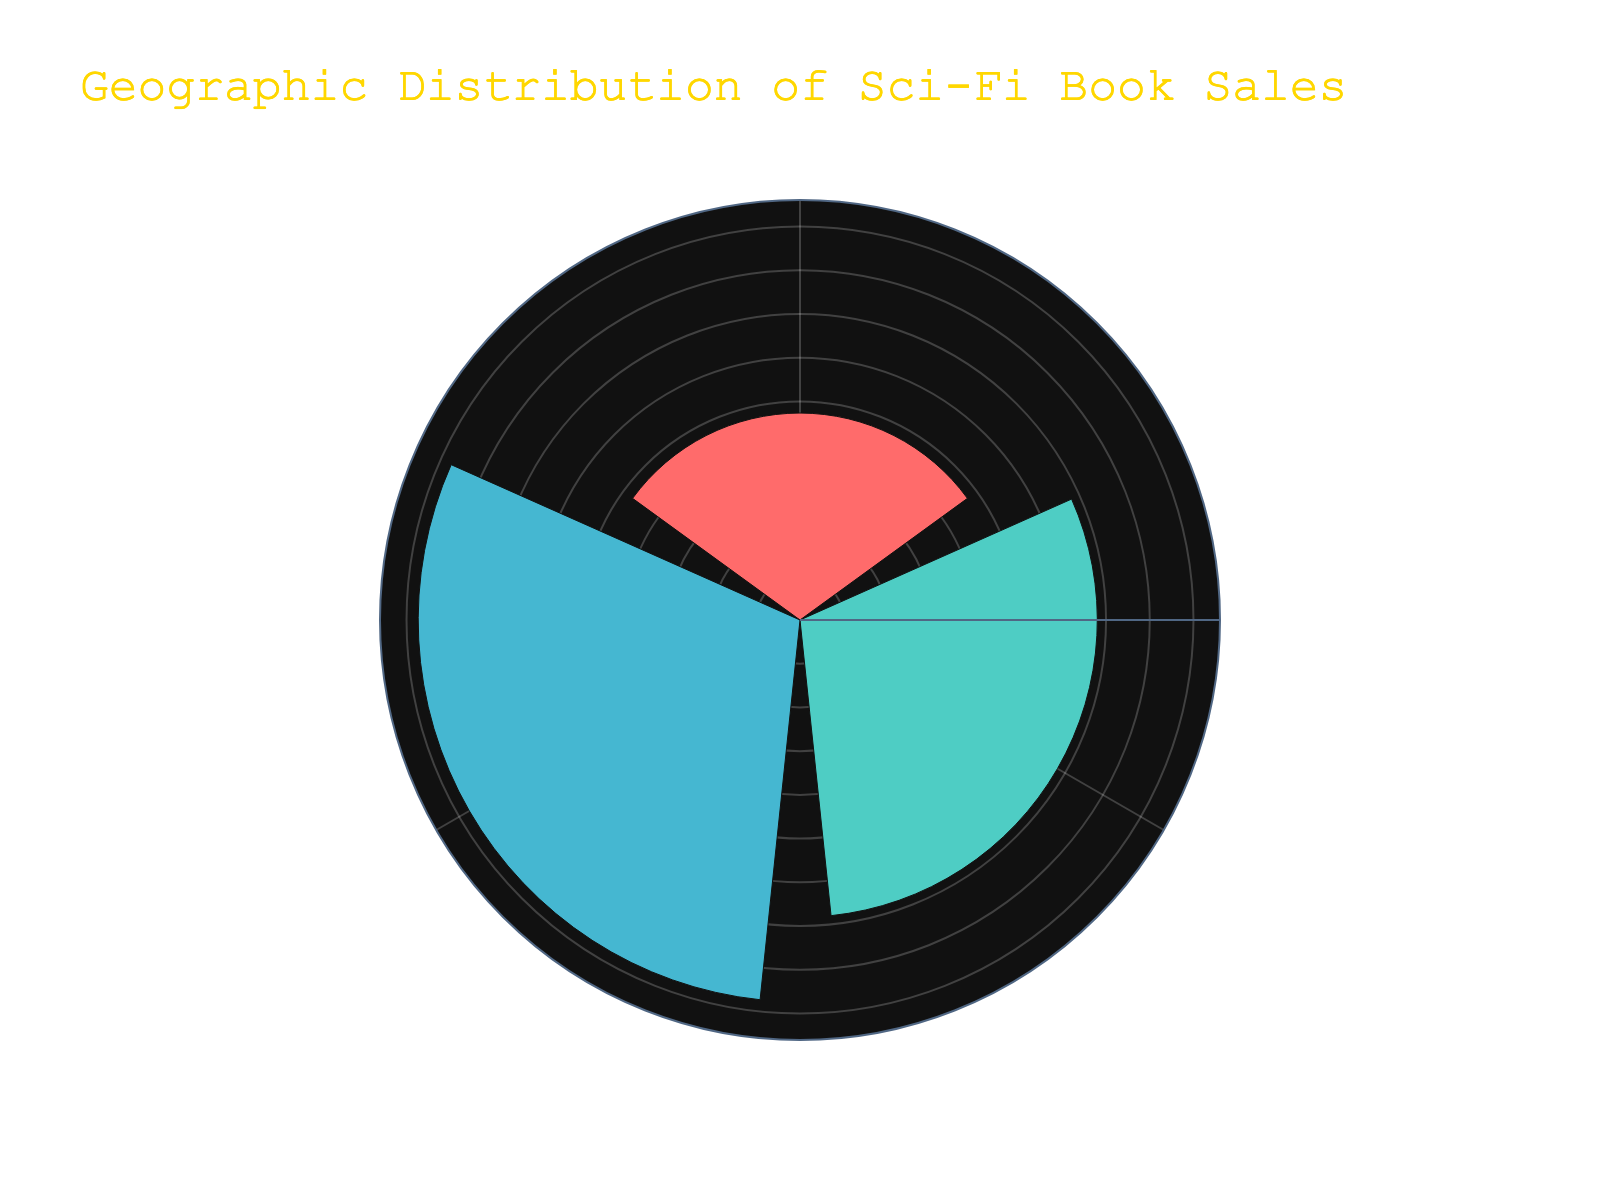What is the title of the rose chart? The title of the rose chart is displayed prominently at the top of the figure and it mentions the geographic distribution of sales.
Answer: Geographic Distribution of Sci-Fi Book Sales What are the regions represented in the rose chart? By looking at the segments labeled on the chart, you can see the specific regions that it represents.
Answer: North America, Europe, Asia Which region has the highest average sales units? To determine the region with the highest average sales units, you would compare the radial lengths of the segments and find the longest one.
Answer: North America What is the approximate average number of sales units in Europe? By looking at the length of the segment for Europe and noting the annotated value near it on the chart, you can estimate the average.
Answer: 68,000 units How does the average sales in Asia compare to those in Europe? To compare, you would look at the lengths of the respective segments and the annotated values for Europe and Asia.
Answer: Asia has fewer average sales than Europe What is the combined average sales of the regions with the two highest averages? First identify the two regions with the highest averages (North America and Europe), then sum their average sales units.
Answer: Combined average is 85,000 (North America) + 68,000 (Europe) = 153,000 units How much higher are the average sales in North America compared to Asia? Subtract the average sales in Asia from the average sales in North America by looking at their values.
Answer: 85,000 (North America) - 47,000 (Asia) = 38,000 units higher Which region's segment is the smallest in the rose chart? Identify the region with the shortest segment on the rose chart.
Answer: Asia How do the average sales units in North America and Europe differ? Subtract Europe’s average sales units from North America's average sales units.
Answer: 85,000 (North America) - 68,000 (Europe) = 17,000 units higher What colors are used to represent the different regions? By inspecting the colors filling each segment, you can identify the distinct ones used for each region.
Answer: Red, Teal, Blue 